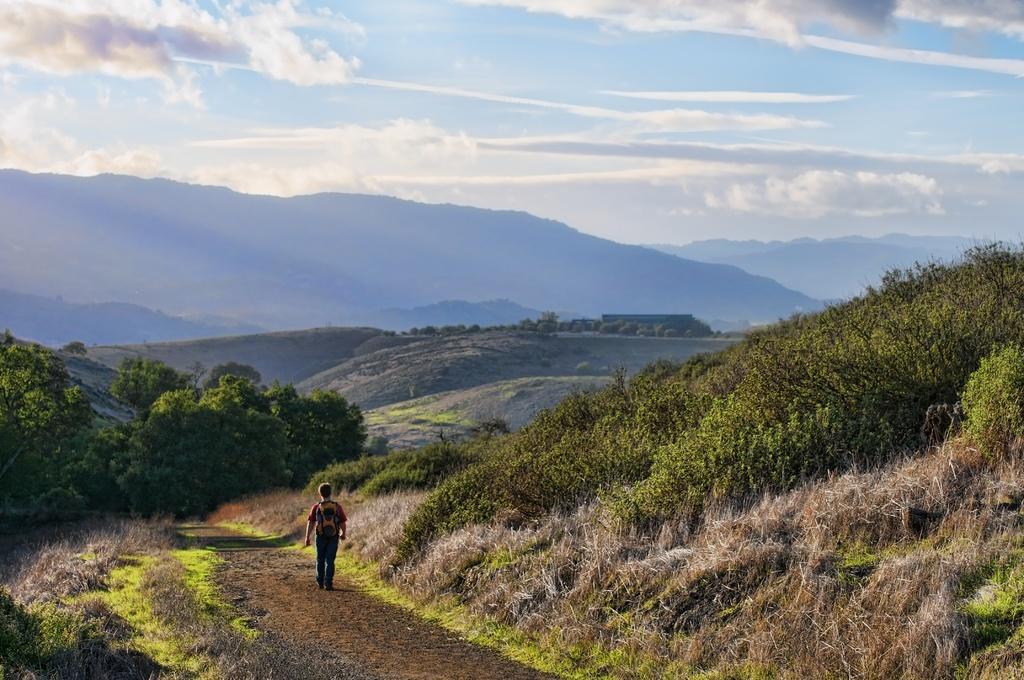Could you give a brief overview of what you see in this image? In this picture we can see a man carrying a bag and walking on a path, trees, mountains and in the background we can see the sky with clouds. 